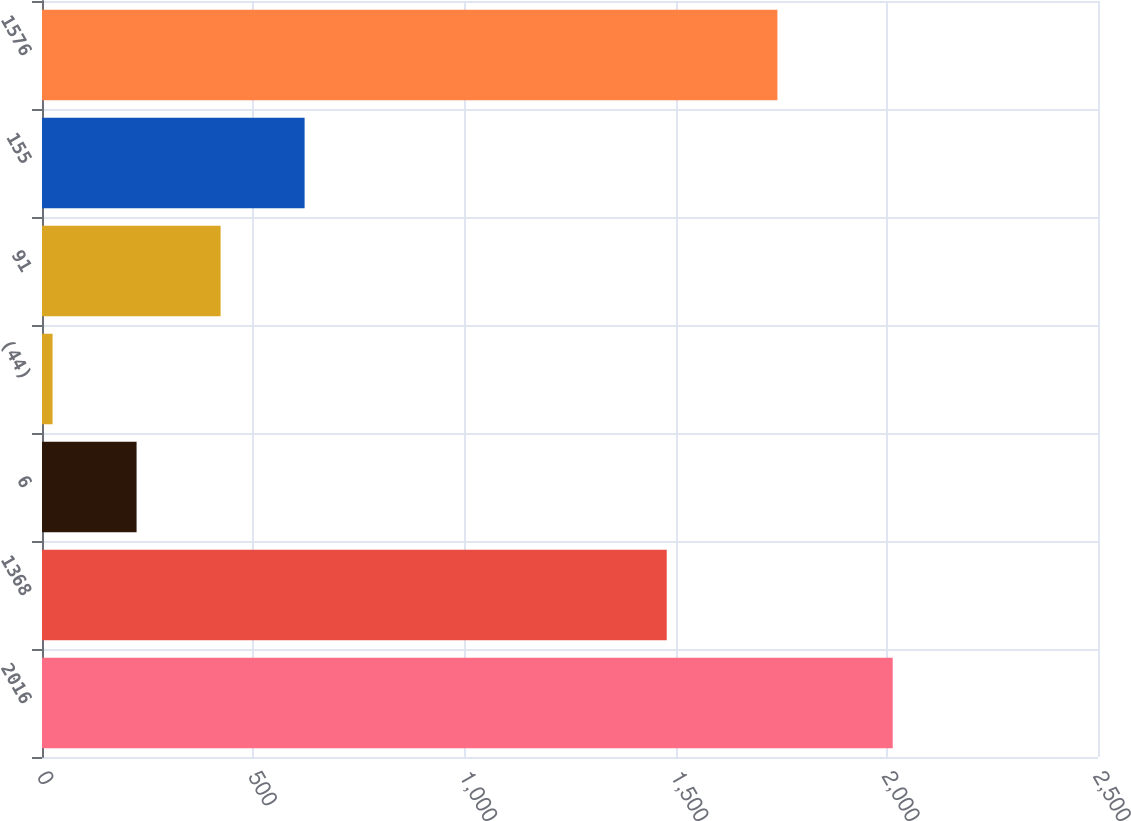Convert chart. <chart><loc_0><loc_0><loc_500><loc_500><bar_chart><fcel>2016<fcel>1368<fcel>6<fcel>(44)<fcel>91<fcel>155<fcel>1576<nl><fcel>2014<fcel>1479<fcel>223.9<fcel>25<fcel>422.8<fcel>621.7<fcel>1741<nl></chart> 